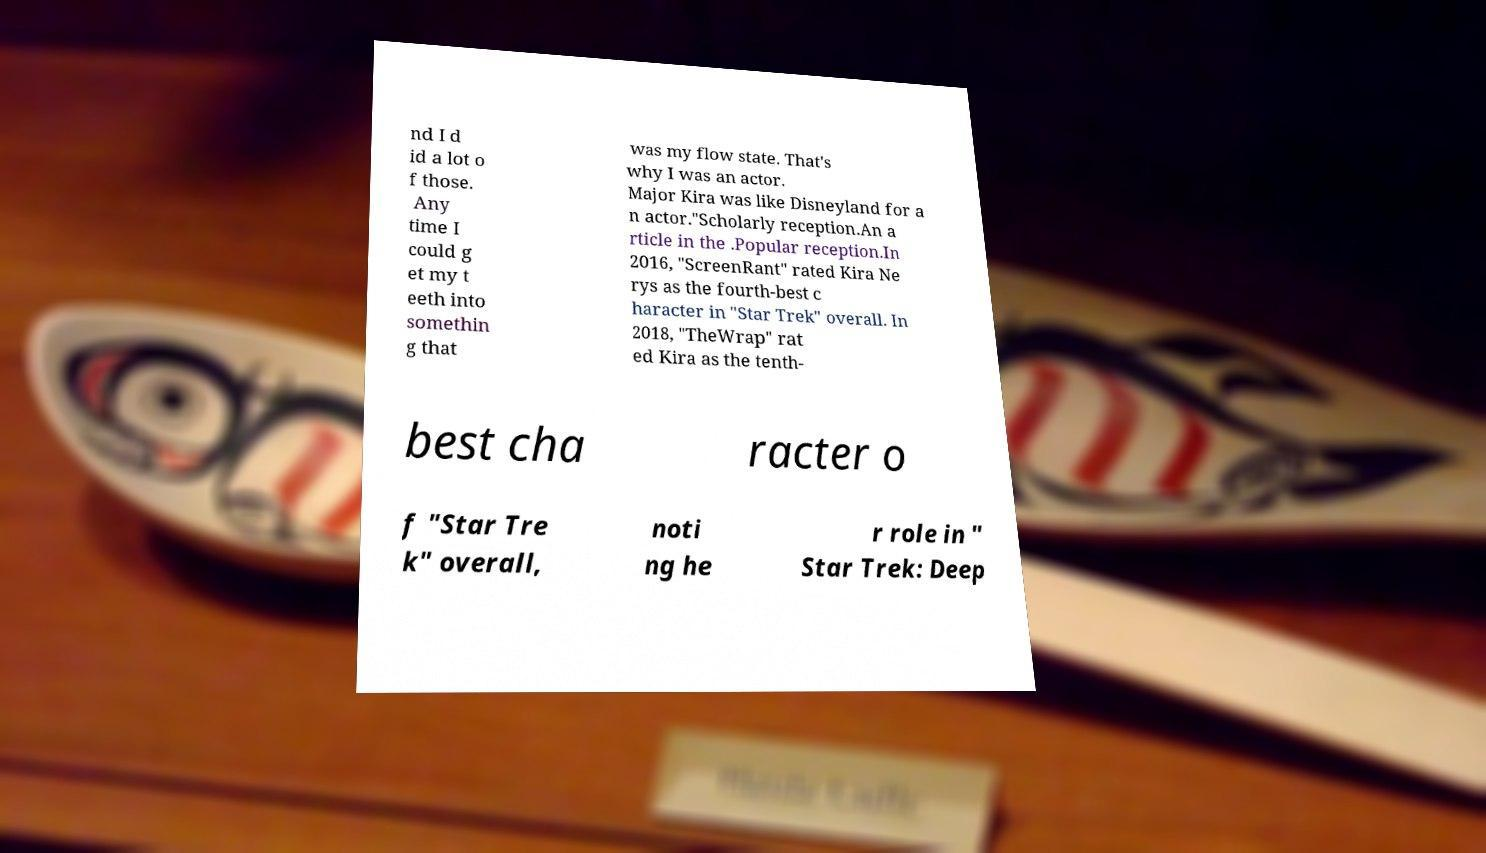Please read and relay the text visible in this image. What does it say? nd I d id a lot o f those. Any time I could g et my t eeth into somethin g that was my flow state. That's why I was an actor. Major Kira was like Disneyland for a n actor."Scholarly reception.An a rticle in the .Popular reception.In 2016, "ScreenRant" rated Kira Ne rys as the fourth-best c haracter in "Star Trek" overall. In 2018, "TheWrap" rat ed Kira as the tenth- best cha racter o f "Star Tre k" overall, noti ng he r role in " Star Trek: Deep 